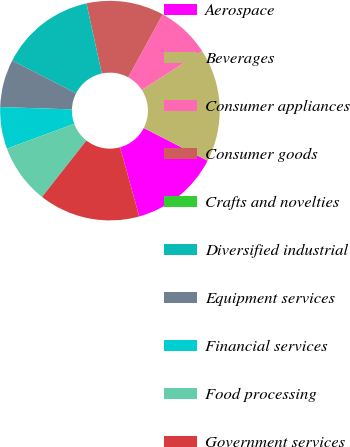Convert chart. <chart><loc_0><loc_0><loc_500><loc_500><pie_chart><fcel>Aerospace<fcel>Beverages<fcel>Consumer appliances<fcel>Consumer goods<fcel>Crafts and novelties<fcel>Diversified industrial<fcel>Equipment services<fcel>Financial services<fcel>Food processing<fcel>Government services<nl><fcel>13.16%<fcel>16.66%<fcel>7.9%<fcel>11.4%<fcel>0.01%<fcel>14.03%<fcel>7.02%<fcel>6.14%<fcel>8.77%<fcel>14.91%<nl></chart> 